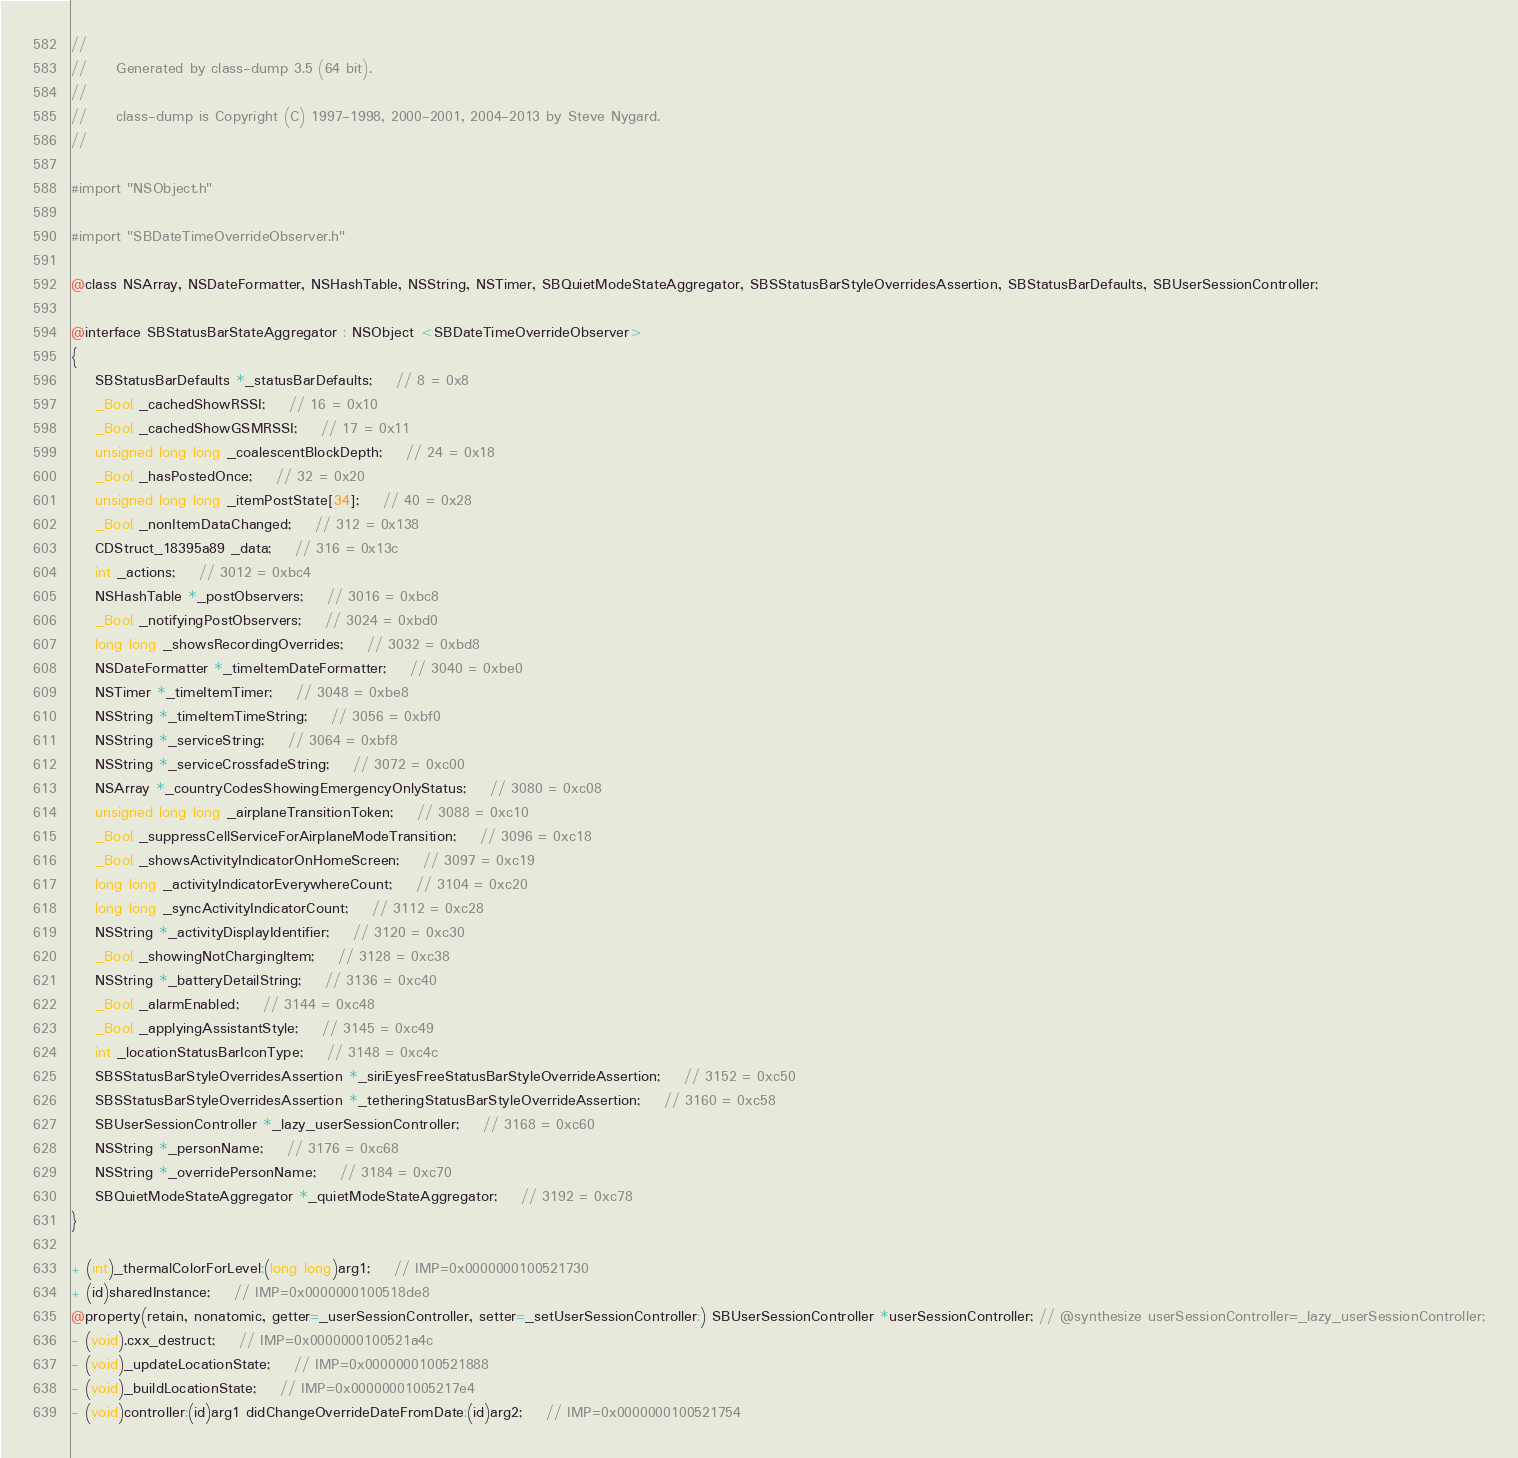<code> <loc_0><loc_0><loc_500><loc_500><_C_>//
//     Generated by class-dump 3.5 (64 bit).
//
//     class-dump is Copyright (C) 1997-1998, 2000-2001, 2004-2013 by Steve Nygard.
//

#import "NSObject.h"

#import "SBDateTimeOverrideObserver.h"

@class NSArray, NSDateFormatter, NSHashTable, NSString, NSTimer, SBQuietModeStateAggregator, SBSStatusBarStyleOverridesAssertion, SBStatusBarDefaults, SBUserSessionController;

@interface SBStatusBarStateAggregator : NSObject <SBDateTimeOverrideObserver>
{
    SBStatusBarDefaults *_statusBarDefaults;	// 8 = 0x8
    _Bool _cachedShowRSSI;	// 16 = 0x10
    _Bool _cachedShowGSMRSSI;	// 17 = 0x11
    unsigned long long _coalescentBlockDepth;	// 24 = 0x18
    _Bool _hasPostedOnce;	// 32 = 0x20
    unsigned long long _itemPostState[34];	// 40 = 0x28
    _Bool _nonItemDataChanged;	// 312 = 0x138
    CDStruct_18395a89 _data;	// 316 = 0x13c
    int _actions;	// 3012 = 0xbc4
    NSHashTable *_postObservers;	// 3016 = 0xbc8
    _Bool _notifyingPostObservers;	// 3024 = 0xbd0
    long long _showsRecordingOverrides;	// 3032 = 0xbd8
    NSDateFormatter *_timeItemDateFormatter;	// 3040 = 0xbe0
    NSTimer *_timeItemTimer;	// 3048 = 0xbe8
    NSString *_timeItemTimeString;	// 3056 = 0xbf0
    NSString *_serviceString;	// 3064 = 0xbf8
    NSString *_serviceCrossfadeString;	// 3072 = 0xc00
    NSArray *_countryCodesShowingEmergencyOnlyStatus;	// 3080 = 0xc08
    unsigned long long _airplaneTransitionToken;	// 3088 = 0xc10
    _Bool _suppressCellServiceForAirplaneModeTransition;	// 3096 = 0xc18
    _Bool _showsActivityIndicatorOnHomeScreen;	// 3097 = 0xc19
    long long _activityIndicatorEverywhereCount;	// 3104 = 0xc20
    long long _syncActivityIndicatorCount;	// 3112 = 0xc28
    NSString *_activityDisplayIdentifier;	// 3120 = 0xc30
    _Bool _showingNotChargingItem;	// 3128 = 0xc38
    NSString *_batteryDetailString;	// 3136 = 0xc40
    _Bool _alarmEnabled;	// 3144 = 0xc48
    _Bool _applyingAssistantStyle;	// 3145 = 0xc49
    int _locationStatusBarIconType;	// 3148 = 0xc4c
    SBSStatusBarStyleOverridesAssertion *_siriEyesFreeStatusBarStyleOverrideAssertion;	// 3152 = 0xc50
    SBSStatusBarStyleOverridesAssertion *_tetheringStatusBarStyleOverrideAssertion;	// 3160 = 0xc58
    SBUserSessionController *_lazy_userSessionController;	// 3168 = 0xc60
    NSString *_personName;	// 3176 = 0xc68
    NSString *_overridePersonName;	// 3184 = 0xc70
    SBQuietModeStateAggregator *_quietModeStateAggregator;	// 3192 = 0xc78
}

+ (int)_thermalColorForLevel:(long long)arg1;	// IMP=0x0000000100521730
+ (id)sharedInstance;	// IMP=0x0000000100518de8
@property(retain, nonatomic, getter=_userSessionController, setter=_setUserSessionController:) SBUserSessionController *userSessionController; // @synthesize userSessionController=_lazy_userSessionController;
- (void).cxx_destruct;	// IMP=0x0000000100521a4c
- (void)_updateLocationState;	// IMP=0x0000000100521888
- (void)_buildLocationState;	// IMP=0x00000001005217e4
- (void)controller:(id)arg1 didChangeOverrideDateFromDate:(id)arg2;	// IMP=0x0000000100521754</code> 